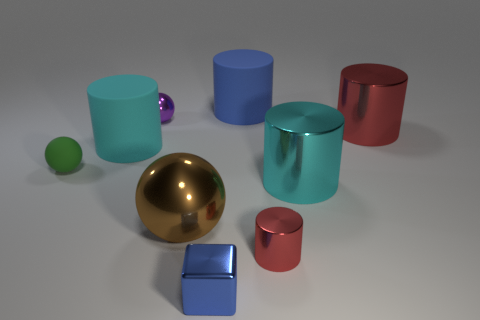There is a matte cylinder behind the cyan matte cylinder; does it have the same color as the shiny cube?
Your answer should be compact. Yes. Are there any purple objects that have the same shape as the tiny green object?
Provide a succinct answer. Yes. What is the color of the metal cylinder that is the same size as the blue cube?
Ensure brevity in your answer.  Red. Does the big object that is behind the large red metal thing have the same material as the tiny blue cube?
Your response must be concise. No. There is a small block that is the same material as the tiny red cylinder; what is its color?
Make the answer very short. Blue. What is the large cyan object on the right side of the small metallic thing behind the red metallic thing behind the small green sphere made of?
Keep it short and to the point. Metal. What material is the small red object?
Make the answer very short. Metal. How many matte things are the same color as the block?
Make the answer very short. 1. There is another big shiny thing that is the same shape as the big red metal object; what is its color?
Give a very brief answer. Cyan. What is the material of the cylinder that is behind the small green sphere and in front of the big red shiny cylinder?
Your answer should be very brief. Rubber. 